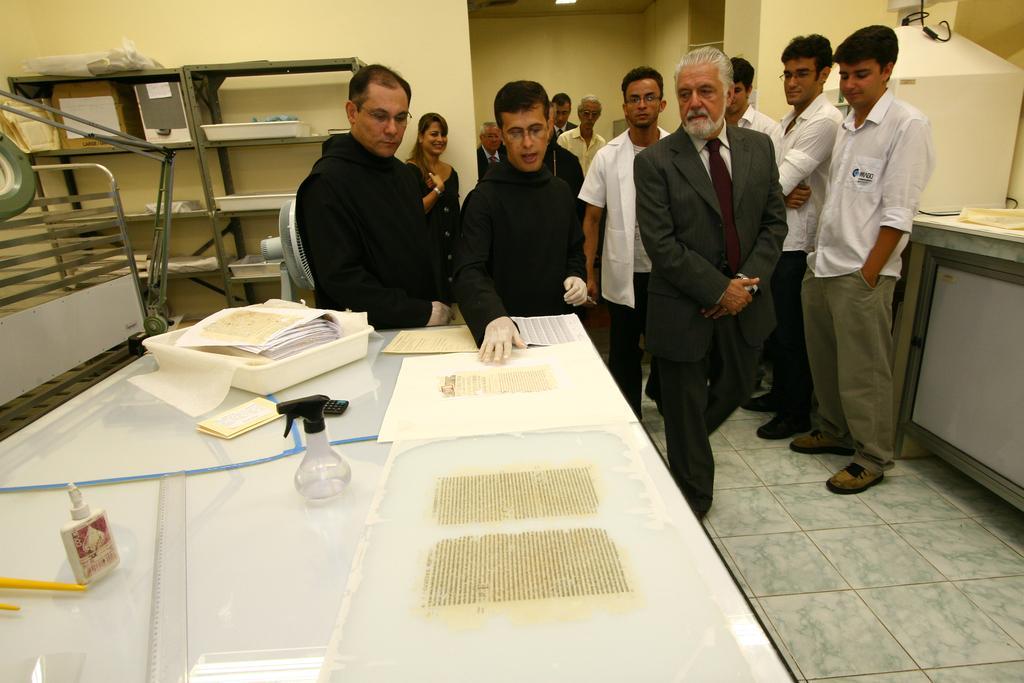Describe this image in one or two sentences. In the image we can see there are people standing and some of them are walking. They are wearing clothes, shoes and two of them are wearing gloves. We can even see there is a table, on the table there are papers, spray bottle, scale and other things. Here we can see the rack and there are objects in the rack. We can see a fence and light. 